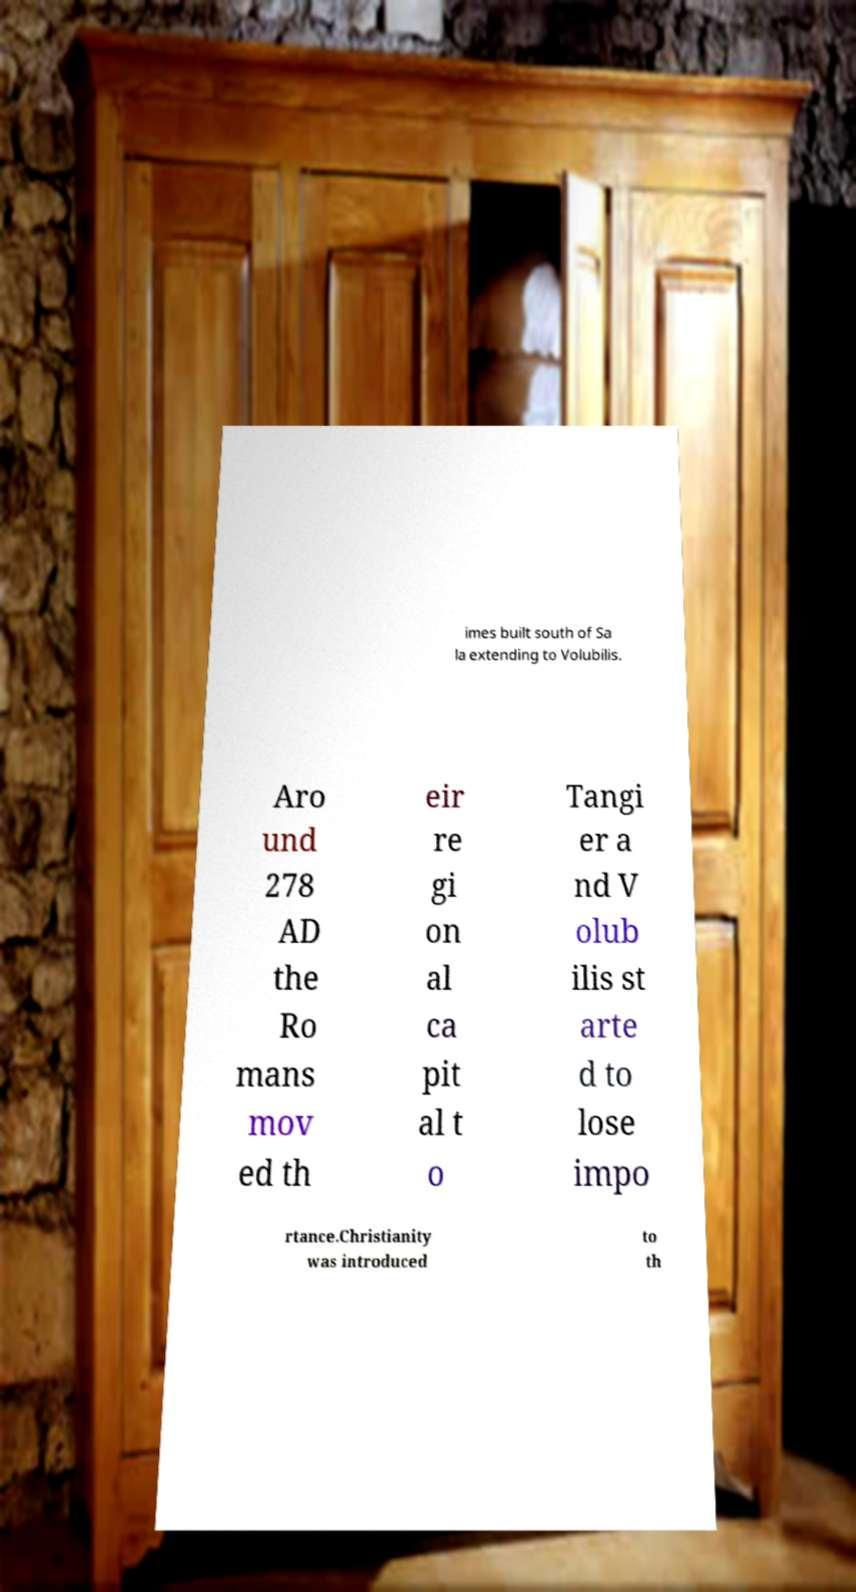Please identify and transcribe the text found in this image. imes built south of Sa la extending to Volubilis. Aro und 278 AD the Ro mans mov ed th eir re gi on al ca pit al t o Tangi er a nd V olub ilis st arte d to lose impo rtance.Christianity was introduced to th 